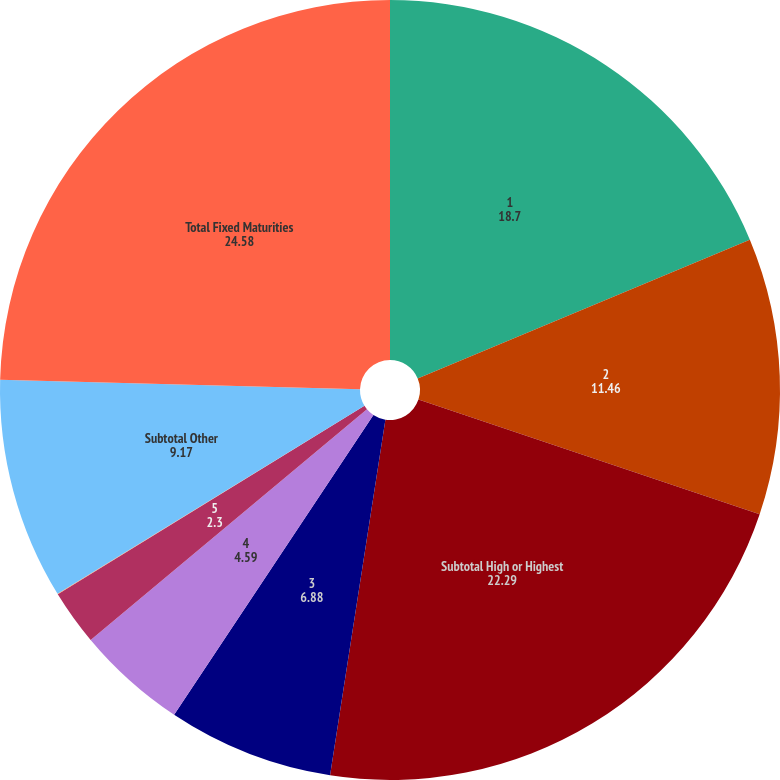Convert chart to OTSL. <chart><loc_0><loc_0><loc_500><loc_500><pie_chart><fcel>1<fcel>2<fcel>Subtotal High or Highest<fcel>3<fcel>4<fcel>5<fcel>6<fcel>Subtotal Other<fcel>Total Fixed Maturities<nl><fcel>18.7%<fcel>11.46%<fcel>22.29%<fcel>6.88%<fcel>4.59%<fcel>2.3%<fcel>0.02%<fcel>9.17%<fcel>24.58%<nl></chart> 